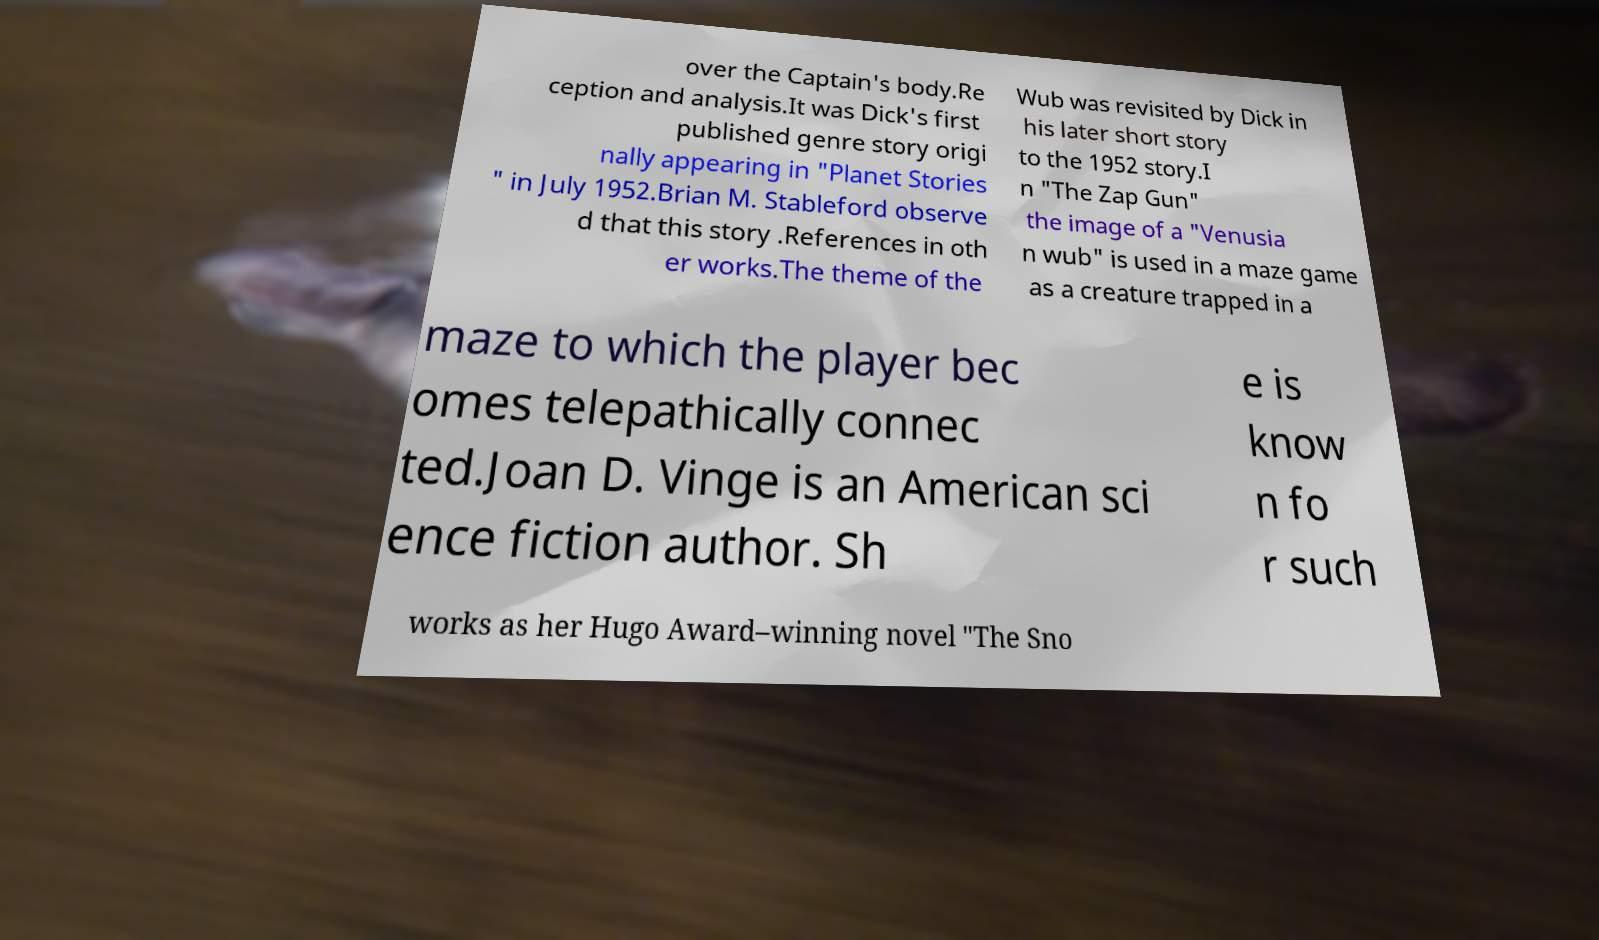Please identify and transcribe the text found in this image. over the Captain's body.Re ception and analysis.It was Dick's first published genre story origi nally appearing in "Planet Stories " in July 1952.Brian M. Stableford observe d that this story .References in oth er works.The theme of the Wub was revisited by Dick in his later short story to the 1952 story.I n "The Zap Gun" the image of a "Venusia n wub" is used in a maze game as a creature trapped in a maze to which the player bec omes telepathically connec ted.Joan D. Vinge is an American sci ence fiction author. Sh e is know n fo r such works as her Hugo Award–winning novel "The Sno 